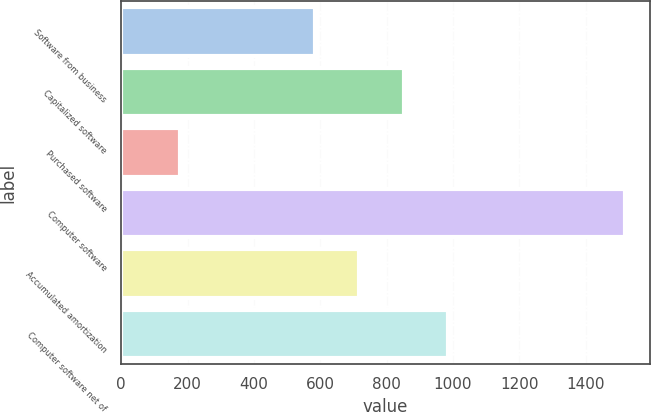Convert chart. <chart><loc_0><loc_0><loc_500><loc_500><bar_chart><fcel>Software from business<fcel>Capitalized software<fcel>Purchased software<fcel>Computer software<fcel>Accumulated amortization<fcel>Computer software net of<nl><fcel>582.7<fcel>850.68<fcel>177.1<fcel>1517<fcel>716.69<fcel>984.67<nl></chart> 